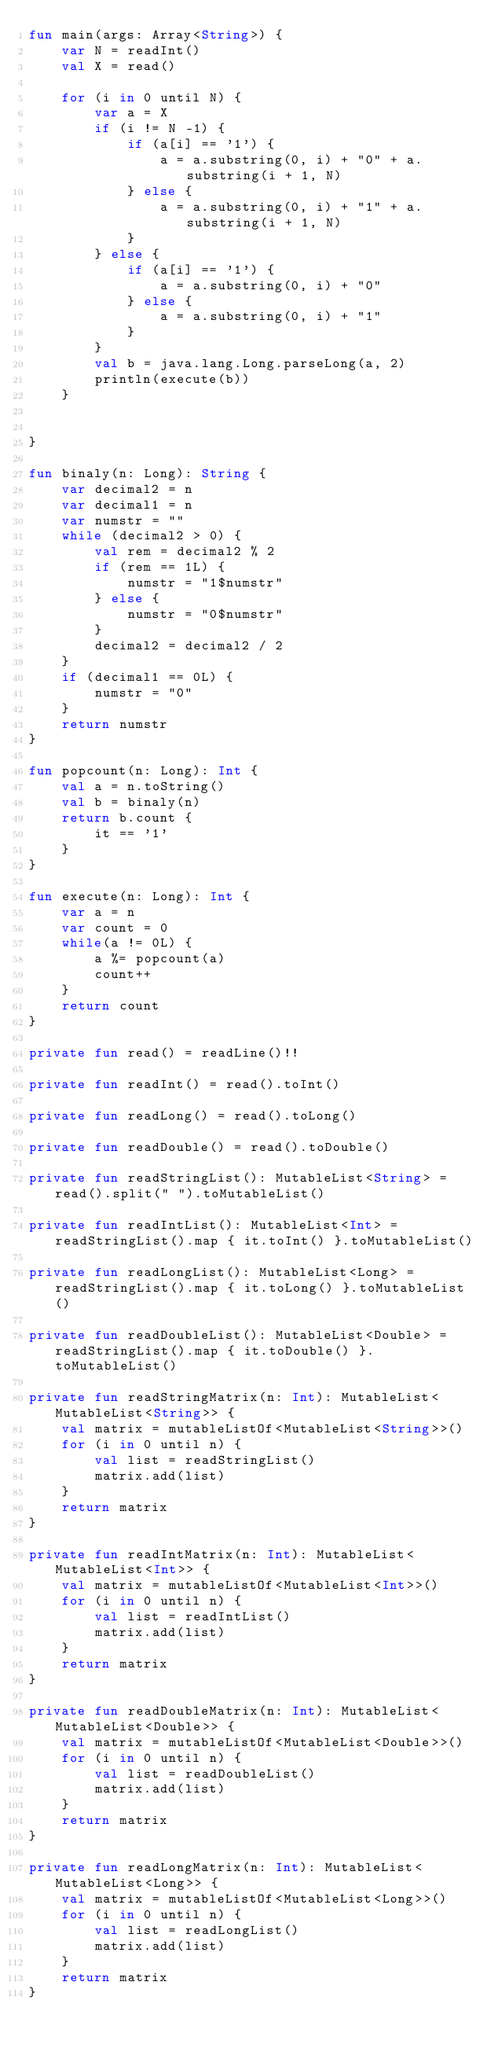<code> <loc_0><loc_0><loc_500><loc_500><_Kotlin_>fun main(args: Array<String>) {
    var N = readInt()
    val X = read()

    for (i in 0 until N) {
        var a = X
        if (i != N -1) {
            if (a[i] == '1') {
                a = a.substring(0, i) + "0" + a.substring(i + 1, N)
            } else {
                a = a.substring(0, i) + "1" + a.substring(i + 1, N)
            }
        } else {
            if (a[i] == '1') {
                a = a.substring(0, i) + "0"
            } else {
                a = a.substring(0, i) + "1"
            }
        }
        val b = java.lang.Long.parseLong(a, 2)
        println(execute(b))
    }


}

fun binaly(n: Long): String {
    var decimal2 = n
    var decimal1 = n
    var numstr = ""
    while (decimal2 > 0) {
        val rem = decimal2 % 2
        if (rem == 1L) {
            numstr = "1$numstr"
        } else {
            numstr = "0$numstr"
        }
        decimal2 = decimal2 / 2
    }
    if (decimal1 == 0L) {
        numstr = "0"
    }
    return numstr
}

fun popcount(n: Long): Int {
    val a = n.toString()
    val b = binaly(n)
    return b.count {
        it == '1'
    }
}

fun execute(n: Long): Int {
    var a = n
    var count = 0
    while(a != 0L) {
        a %= popcount(a)
        count++
    }
    return count
}

private fun read() = readLine()!!

private fun readInt() = read().toInt()

private fun readLong() = read().toLong()

private fun readDouble() = read().toDouble()

private fun readStringList(): MutableList<String> = read().split(" ").toMutableList()

private fun readIntList(): MutableList<Int> = readStringList().map { it.toInt() }.toMutableList()

private fun readLongList(): MutableList<Long> = readStringList().map { it.toLong() }.toMutableList()

private fun readDoubleList(): MutableList<Double> = readStringList().map { it.toDouble() }.toMutableList()

private fun readStringMatrix(n: Int): MutableList<MutableList<String>> {
    val matrix = mutableListOf<MutableList<String>>()
    for (i in 0 until n) {
        val list = readStringList()
        matrix.add(list)
    }
    return matrix
}

private fun readIntMatrix(n: Int): MutableList<MutableList<Int>> {
    val matrix = mutableListOf<MutableList<Int>>()
    for (i in 0 until n) {
        val list = readIntList()
        matrix.add(list)
    }
    return matrix
}

private fun readDoubleMatrix(n: Int): MutableList<MutableList<Double>> {
    val matrix = mutableListOf<MutableList<Double>>()
    for (i in 0 until n) {
        val list = readDoubleList()
        matrix.add(list)
    }
    return matrix
}

private fun readLongMatrix(n: Int): MutableList<MutableList<Long>> {
    val matrix = mutableListOf<MutableList<Long>>()
    for (i in 0 until n) {
        val list = readLongList()
        matrix.add(list)
    }
    return matrix
}

</code> 